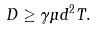<formula> <loc_0><loc_0><loc_500><loc_500>D \geq \gamma \mu d ^ { 2 } T .</formula> 